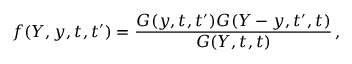<formula> <loc_0><loc_0><loc_500><loc_500>f ( Y , y , t , t ^ { \prime } ) = \frac { G ( y , t , t ^ { \prime } ) G ( Y - y , t ^ { \prime } , t ) } { G ( Y , t , t ) } \, ,</formula> 